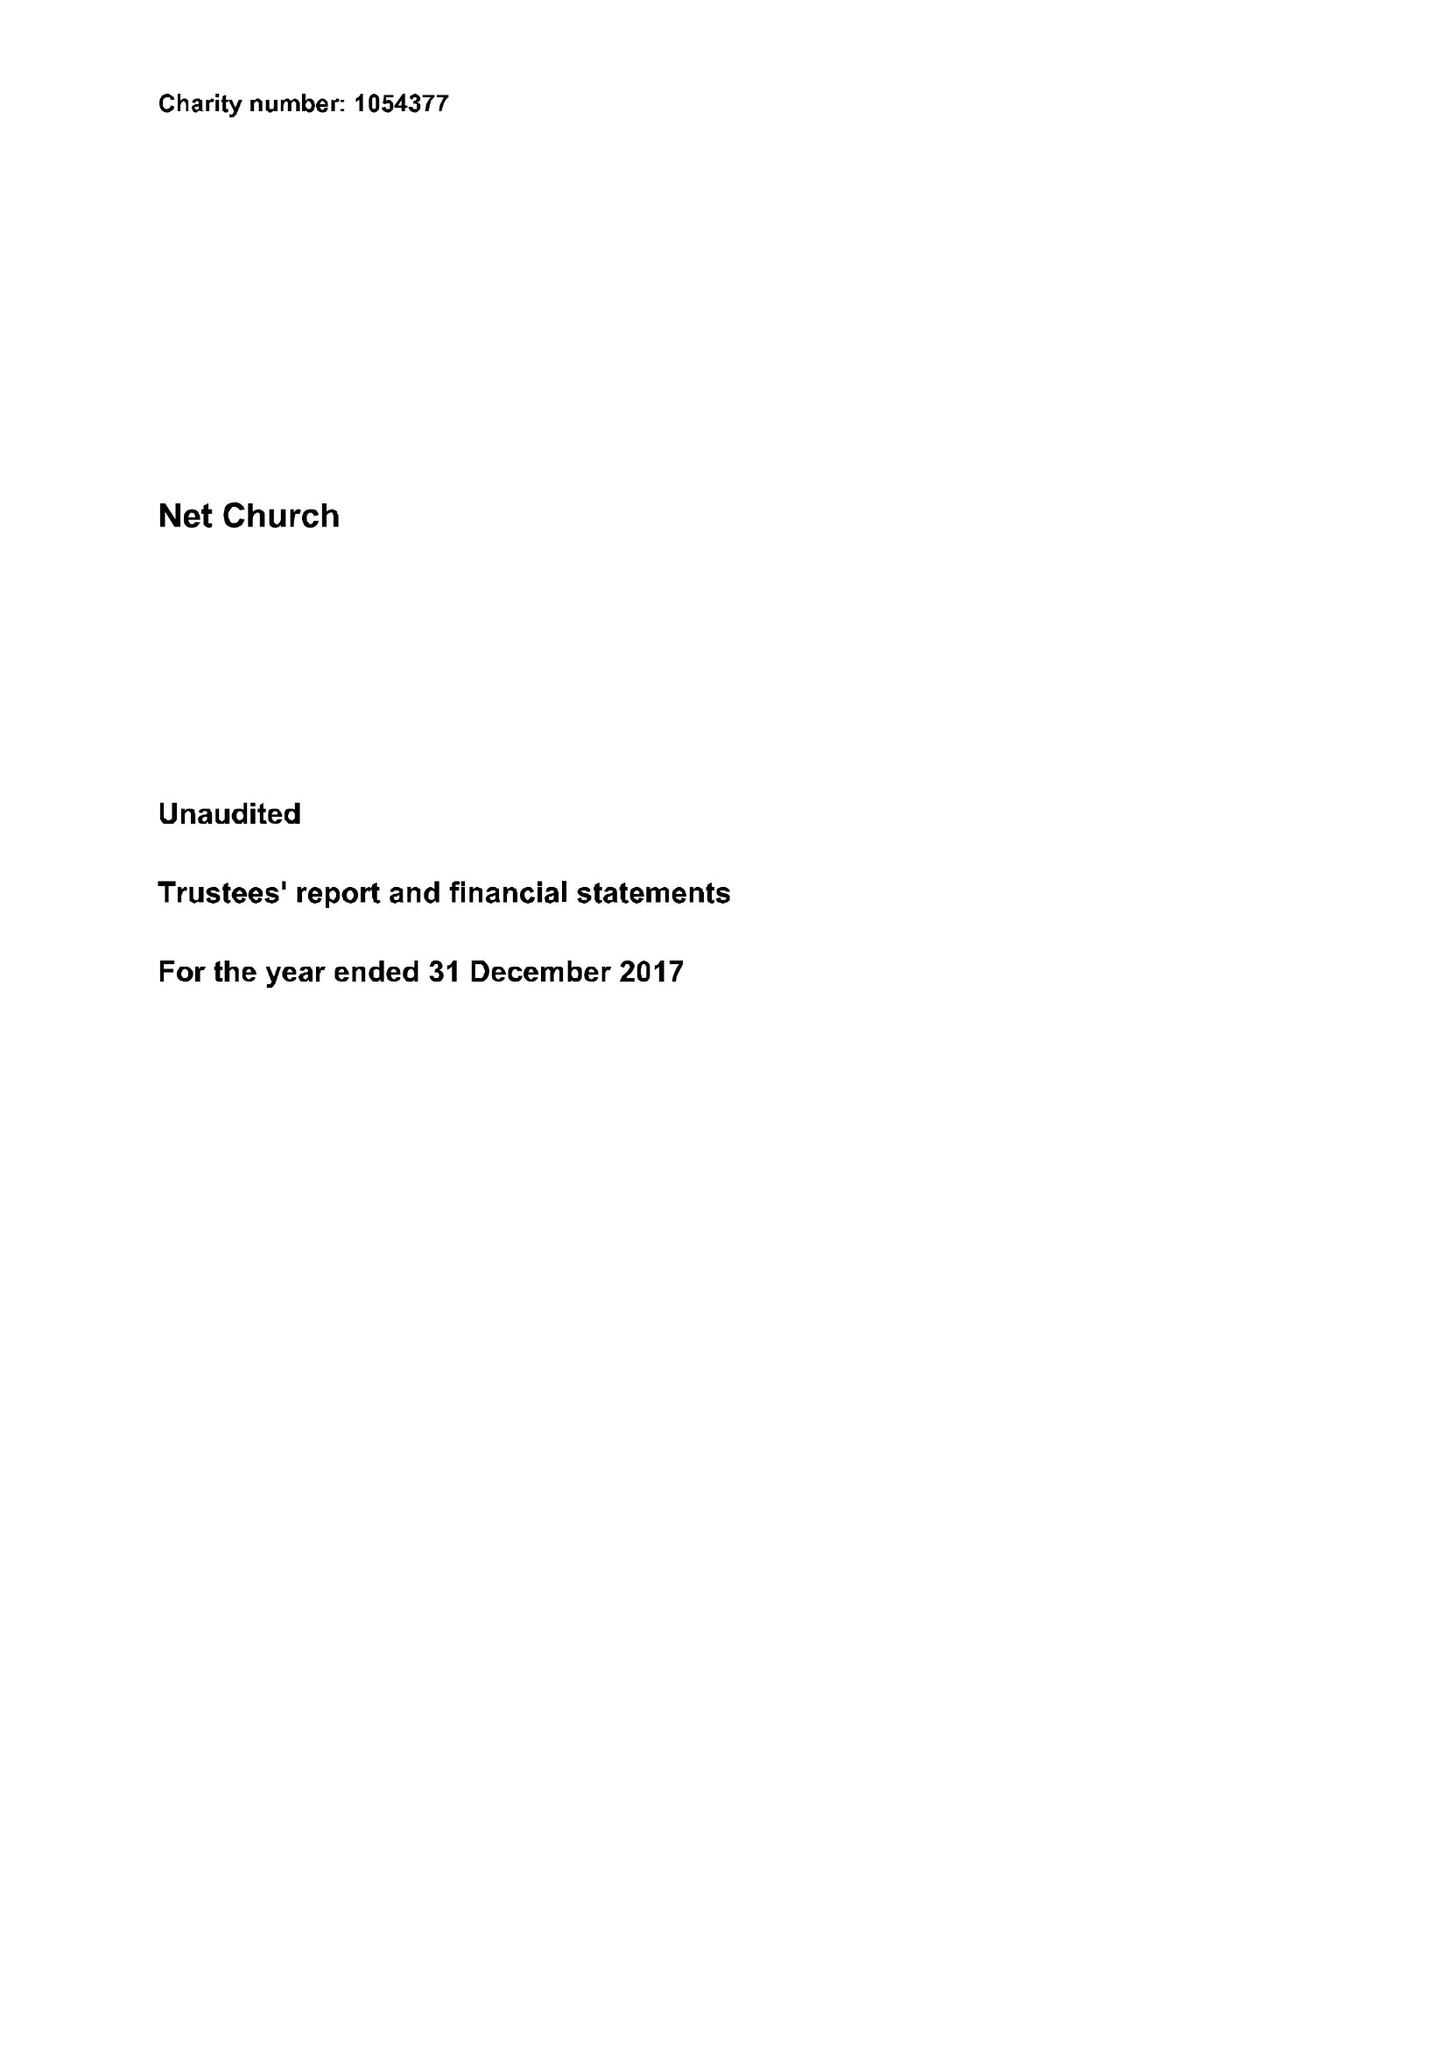What is the value for the report_date?
Answer the question using a single word or phrase. 2017-12-31 